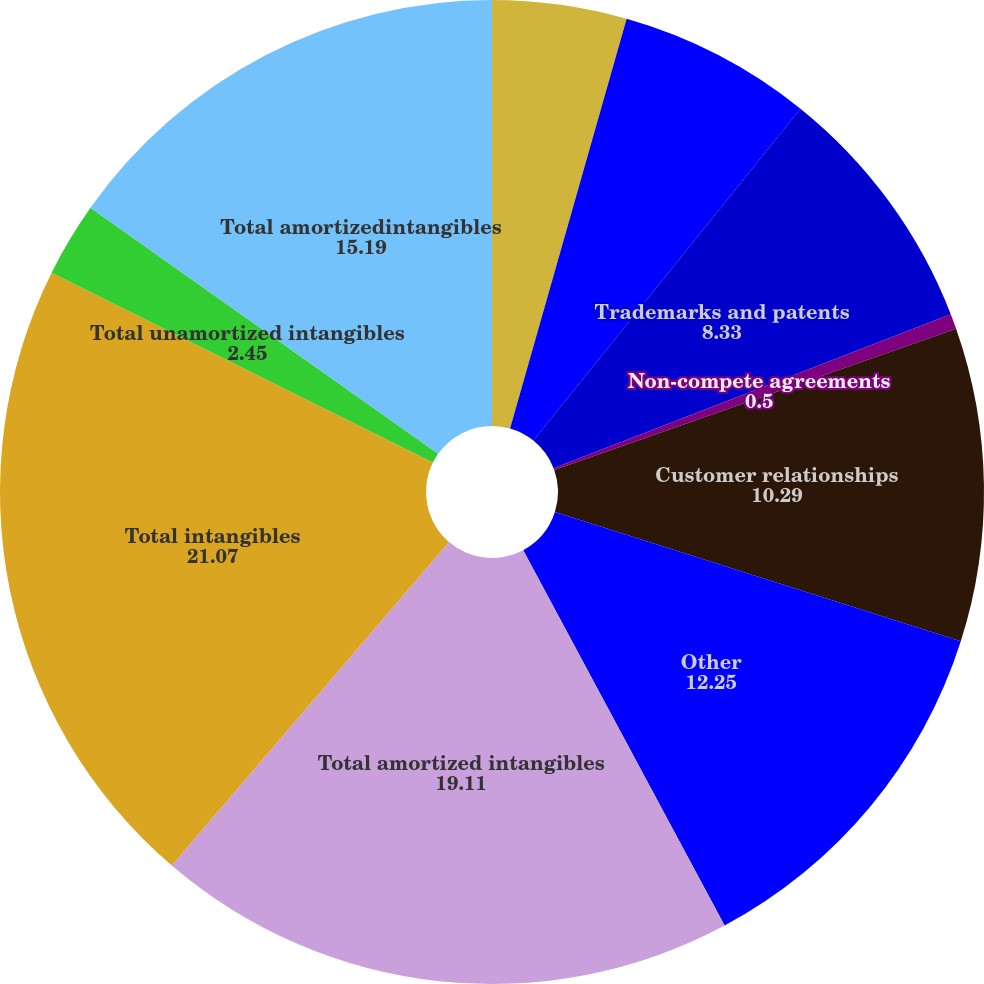Convert chart to OTSL. <chart><loc_0><loc_0><loc_500><loc_500><pie_chart><fcel>Trademarksand patents<fcel>Total unamortizedintangibles<fcel>Trademarks and patents<fcel>Non-compete agreements<fcel>Customer relationships<fcel>Other<fcel>Total amortized intangibles<fcel>Total intangibles<fcel>Total unamortized intangibles<fcel>Total amortizedintangibles<nl><fcel>4.41%<fcel>6.37%<fcel>8.33%<fcel>0.5%<fcel>10.29%<fcel>12.25%<fcel>19.11%<fcel>21.07%<fcel>2.45%<fcel>15.19%<nl></chart> 